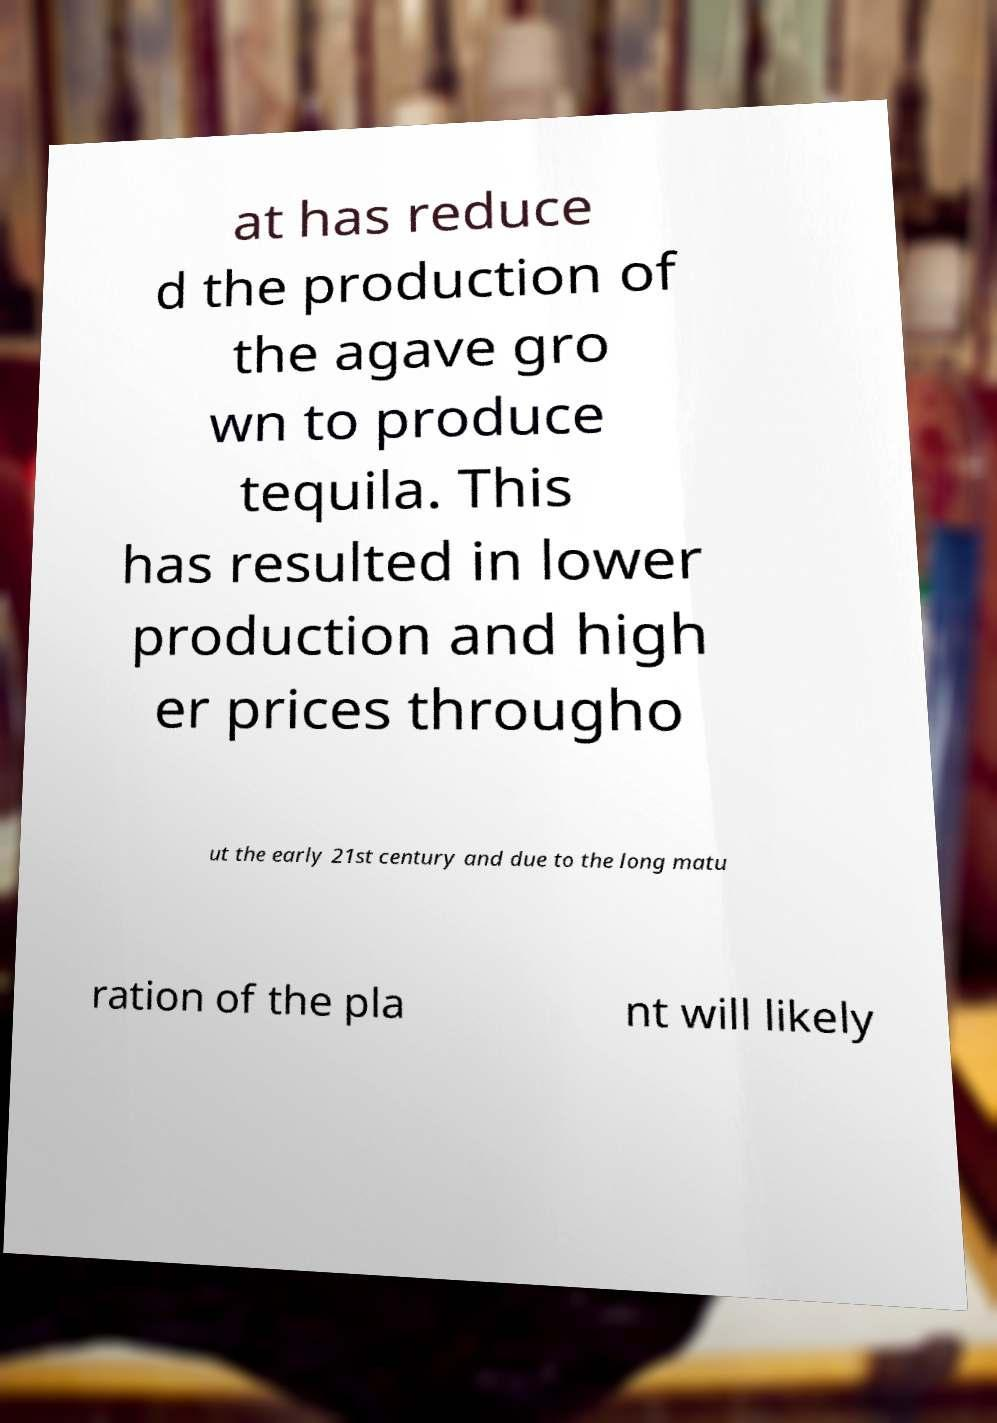I need the written content from this picture converted into text. Can you do that? at has reduce d the production of the agave gro wn to produce tequila. This has resulted in lower production and high er prices througho ut the early 21st century and due to the long matu ration of the pla nt will likely 